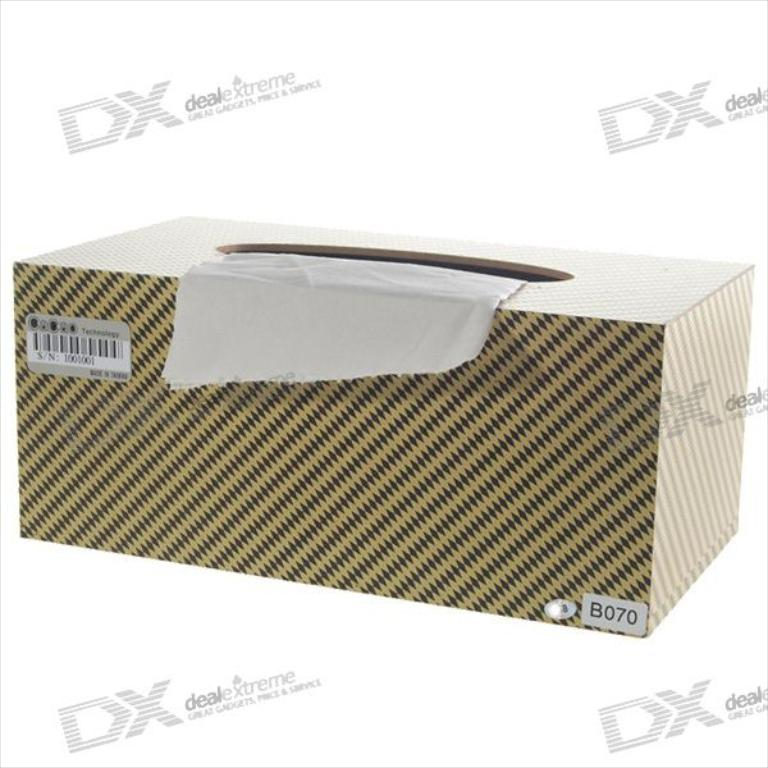What are some possible uses for this box of tissues beyond its intended purpose? This box of tissues can be creatively repurposed for storing small household items or as a decorative container for craft supplies, aiding in organizing and adding a stylish touch to home decor. 